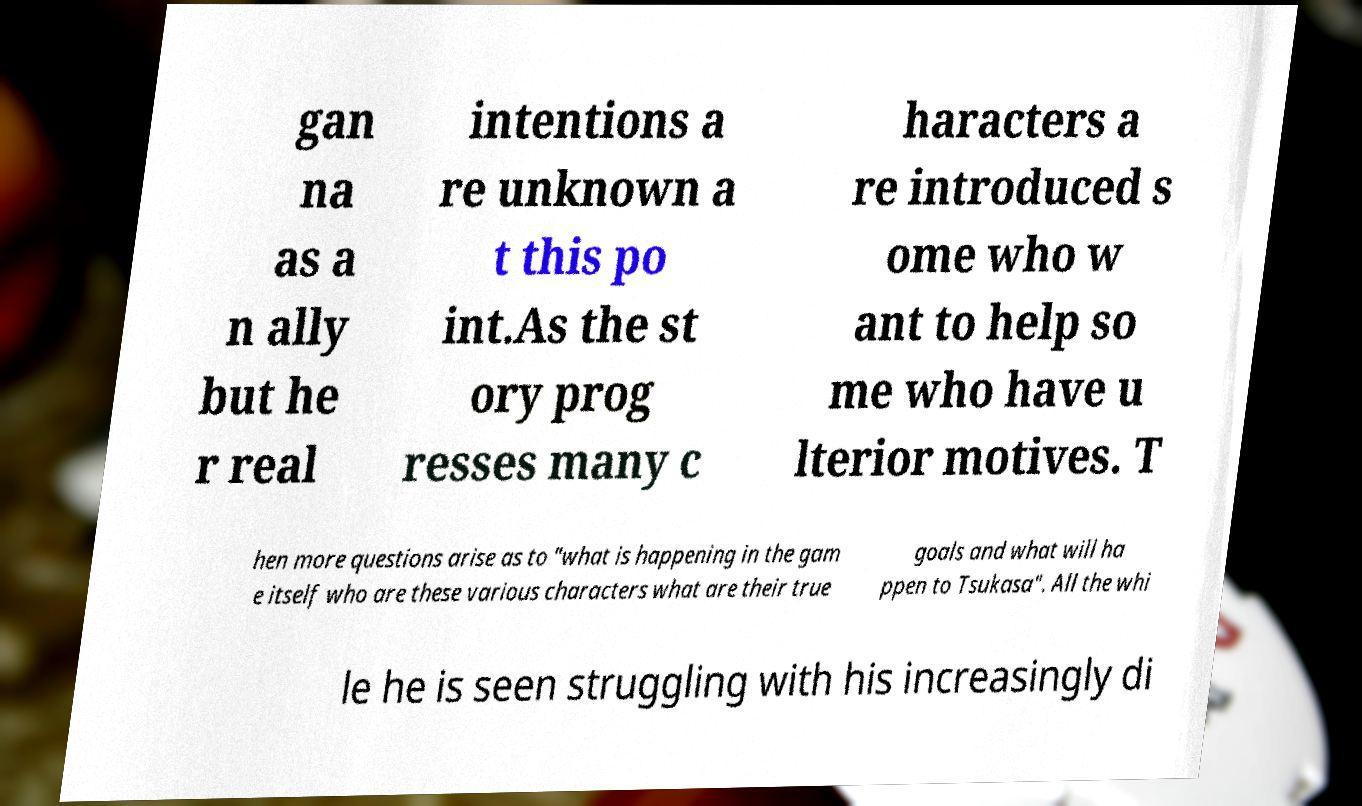There's text embedded in this image that I need extracted. Can you transcribe it verbatim? gan na as a n ally but he r real intentions a re unknown a t this po int.As the st ory prog resses many c haracters a re introduced s ome who w ant to help so me who have u lterior motives. T hen more questions arise as to "what is happening in the gam e itself who are these various characters what are their true goals and what will ha ppen to Tsukasa". All the whi le he is seen struggling with his increasingly di 